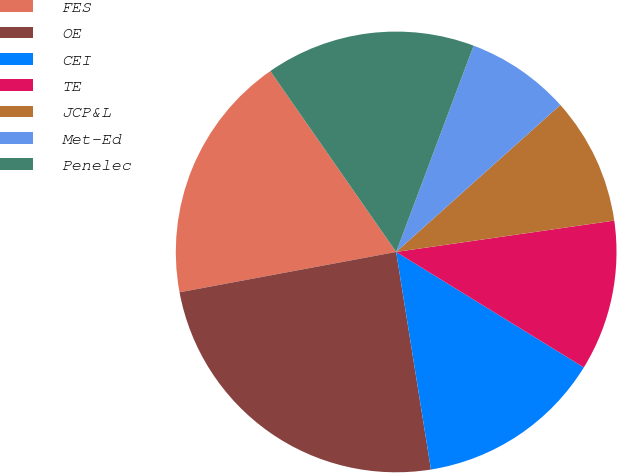<chart> <loc_0><loc_0><loc_500><loc_500><pie_chart><fcel>FES<fcel>OE<fcel>CEI<fcel>TE<fcel>JCP&L<fcel>Met-Ed<fcel>Penelec<nl><fcel>18.26%<fcel>24.59%<fcel>13.7%<fcel>11.05%<fcel>9.35%<fcel>7.66%<fcel>15.39%<nl></chart> 